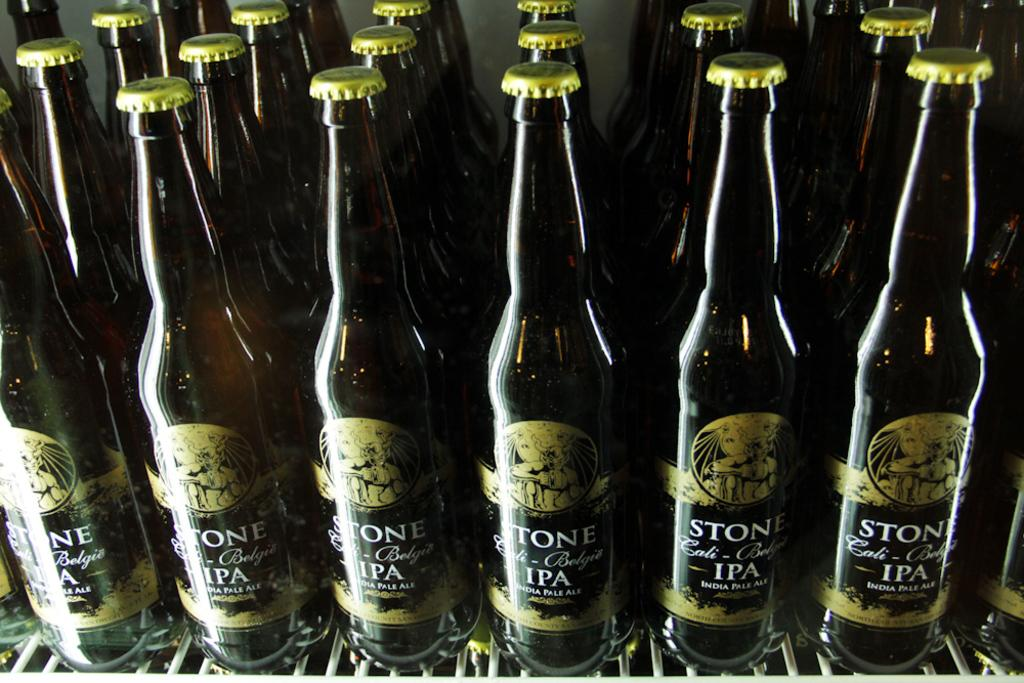<image>
Present a compact description of the photo's key features. The shelf is full of Stone IPA beer. 